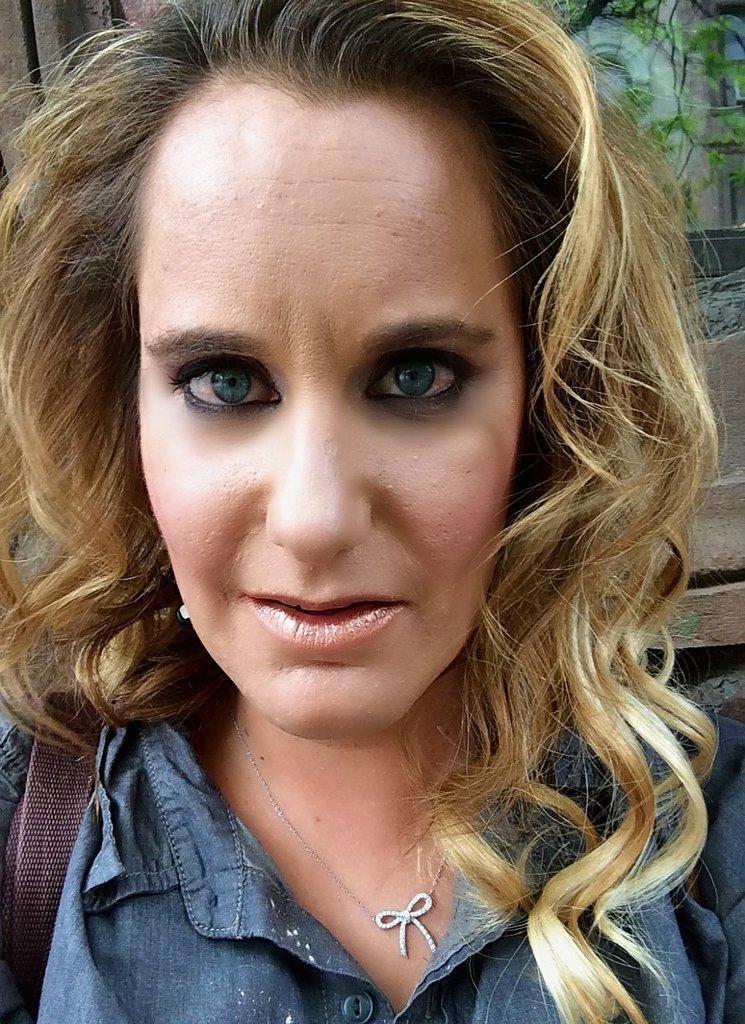How would you summarize this image in a sentence or two? In the foreground of this picture, there is a woman in blue shirt wearing a bag and she is having a blonde colored hair. In the background, there is a building and a tree. 